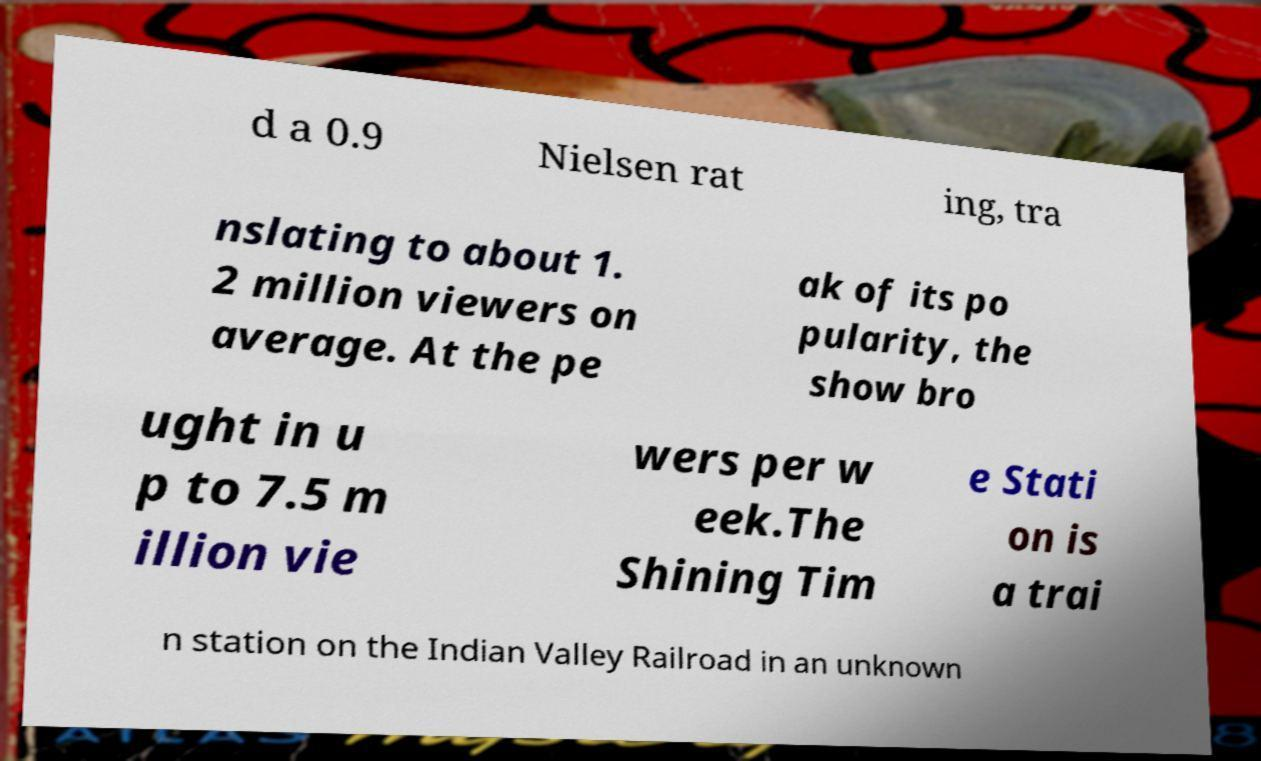Please read and relay the text visible in this image. What does it say? d a 0.9 Nielsen rat ing, tra nslating to about 1. 2 million viewers on average. At the pe ak of its po pularity, the show bro ught in u p to 7.5 m illion vie wers per w eek.The Shining Tim e Stati on is a trai n station on the Indian Valley Railroad in an unknown 